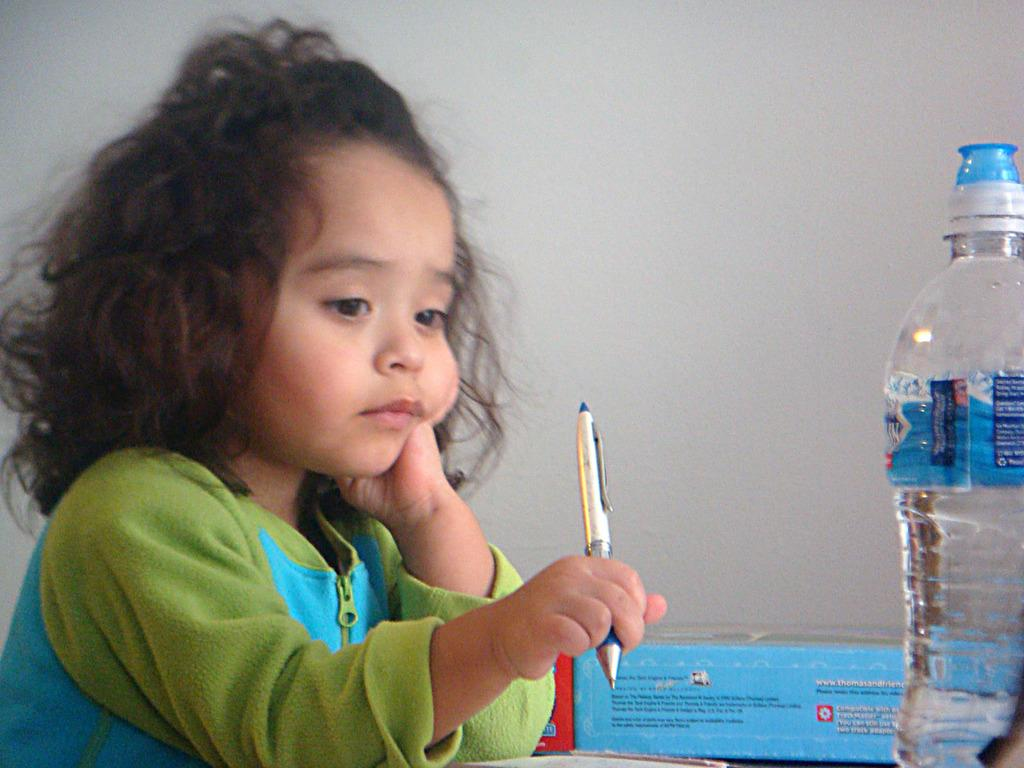What is the main subject of the image? The main subject of the image is a kid. What is the kid holding in the image? The kid is holding a pen. What other object can be seen in the image? There is a water bottle in the image. Can you describe another item in the image? There is a blue box in the image. How many kittens are playing with the snake in the image? There are no kittens or snakes present in the image. What type of yam is being used as a paperweight on the blue box? There is no yam present in the image, and the blue box does not have any paperweight on it. 